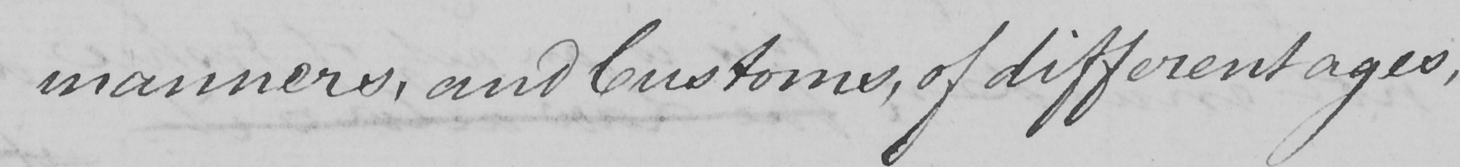Can you tell me what this handwritten text says? manners , and Customs , of different ages , 